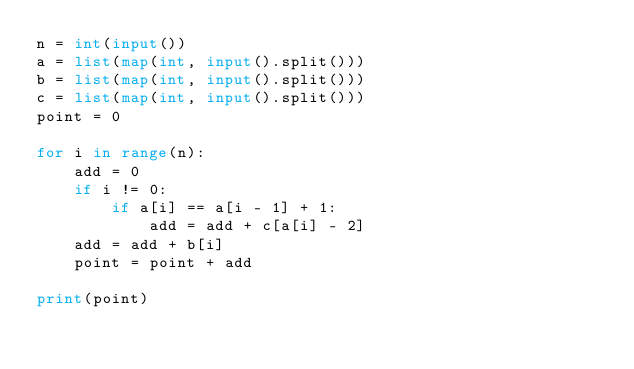Convert code to text. <code><loc_0><loc_0><loc_500><loc_500><_Python_>n = int(input())
a = list(map(int, input().split()))
b = list(map(int, input().split()))
c = list(map(int, input().split()))
point = 0

for i in range(n):
    add = 0
    if i != 0:
        if a[i] == a[i - 1] + 1:
            add = add + c[a[i] - 2]
    add = add + b[i]
    point = point + add

print(point)</code> 